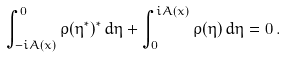<formula> <loc_0><loc_0><loc_500><loc_500>\int _ { - i A ( x ) } ^ { 0 } \rho ( \eta ^ { * } ) ^ { * } \, d \eta + \int _ { 0 } ^ { i A ( x ) } \rho ( \eta ) \, d \eta = 0 \, .</formula> 